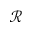<formula> <loc_0><loc_0><loc_500><loc_500>\mathcal { R }</formula> 